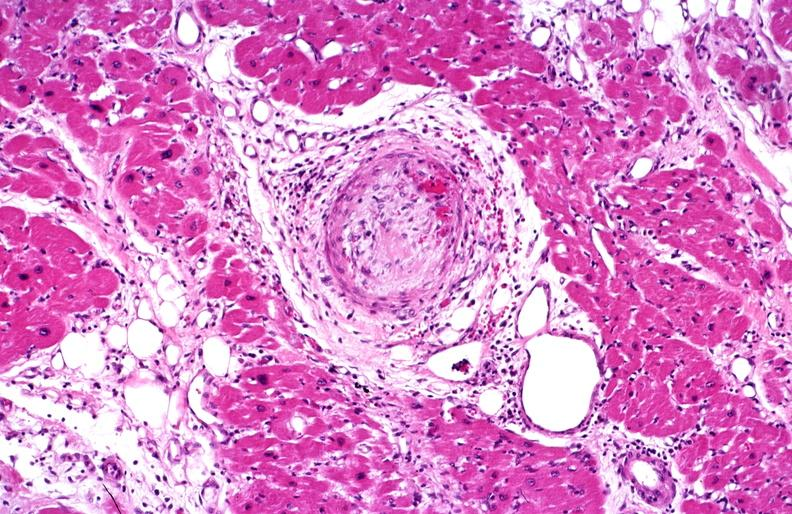what is present?
Answer the question using a single word or phrase. Cardiovascular 